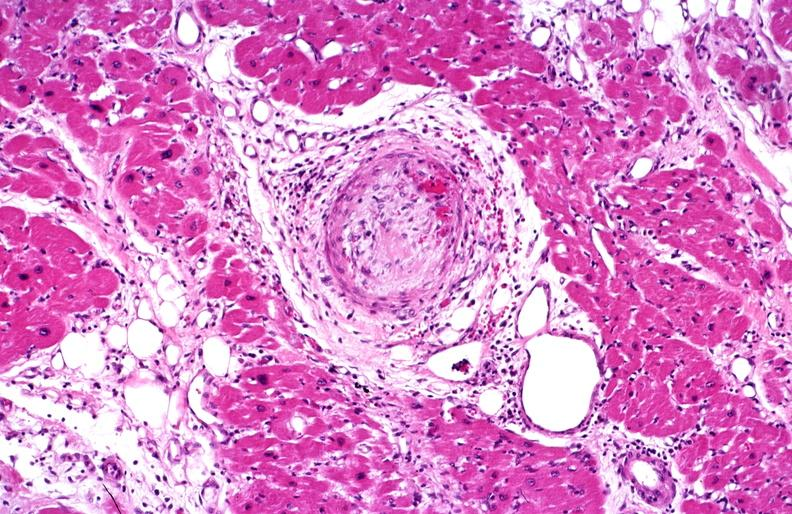what is present?
Answer the question using a single word or phrase. Cardiovascular 